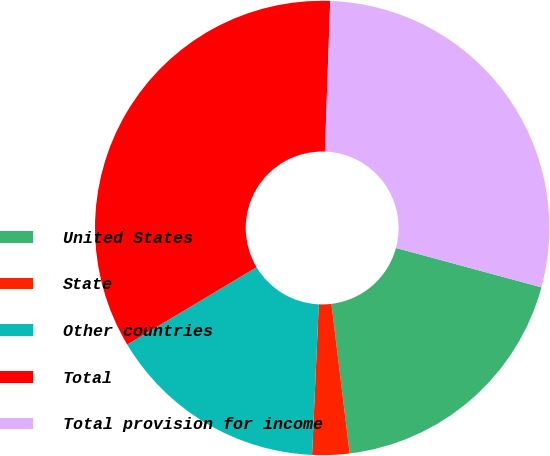<chart> <loc_0><loc_0><loc_500><loc_500><pie_chart><fcel>United States<fcel>State<fcel>Other countries<fcel>Total<fcel>Total provision for income<nl><fcel>18.86%<fcel>2.64%<fcel>15.71%<fcel>34.14%<fcel>28.64%<nl></chart> 